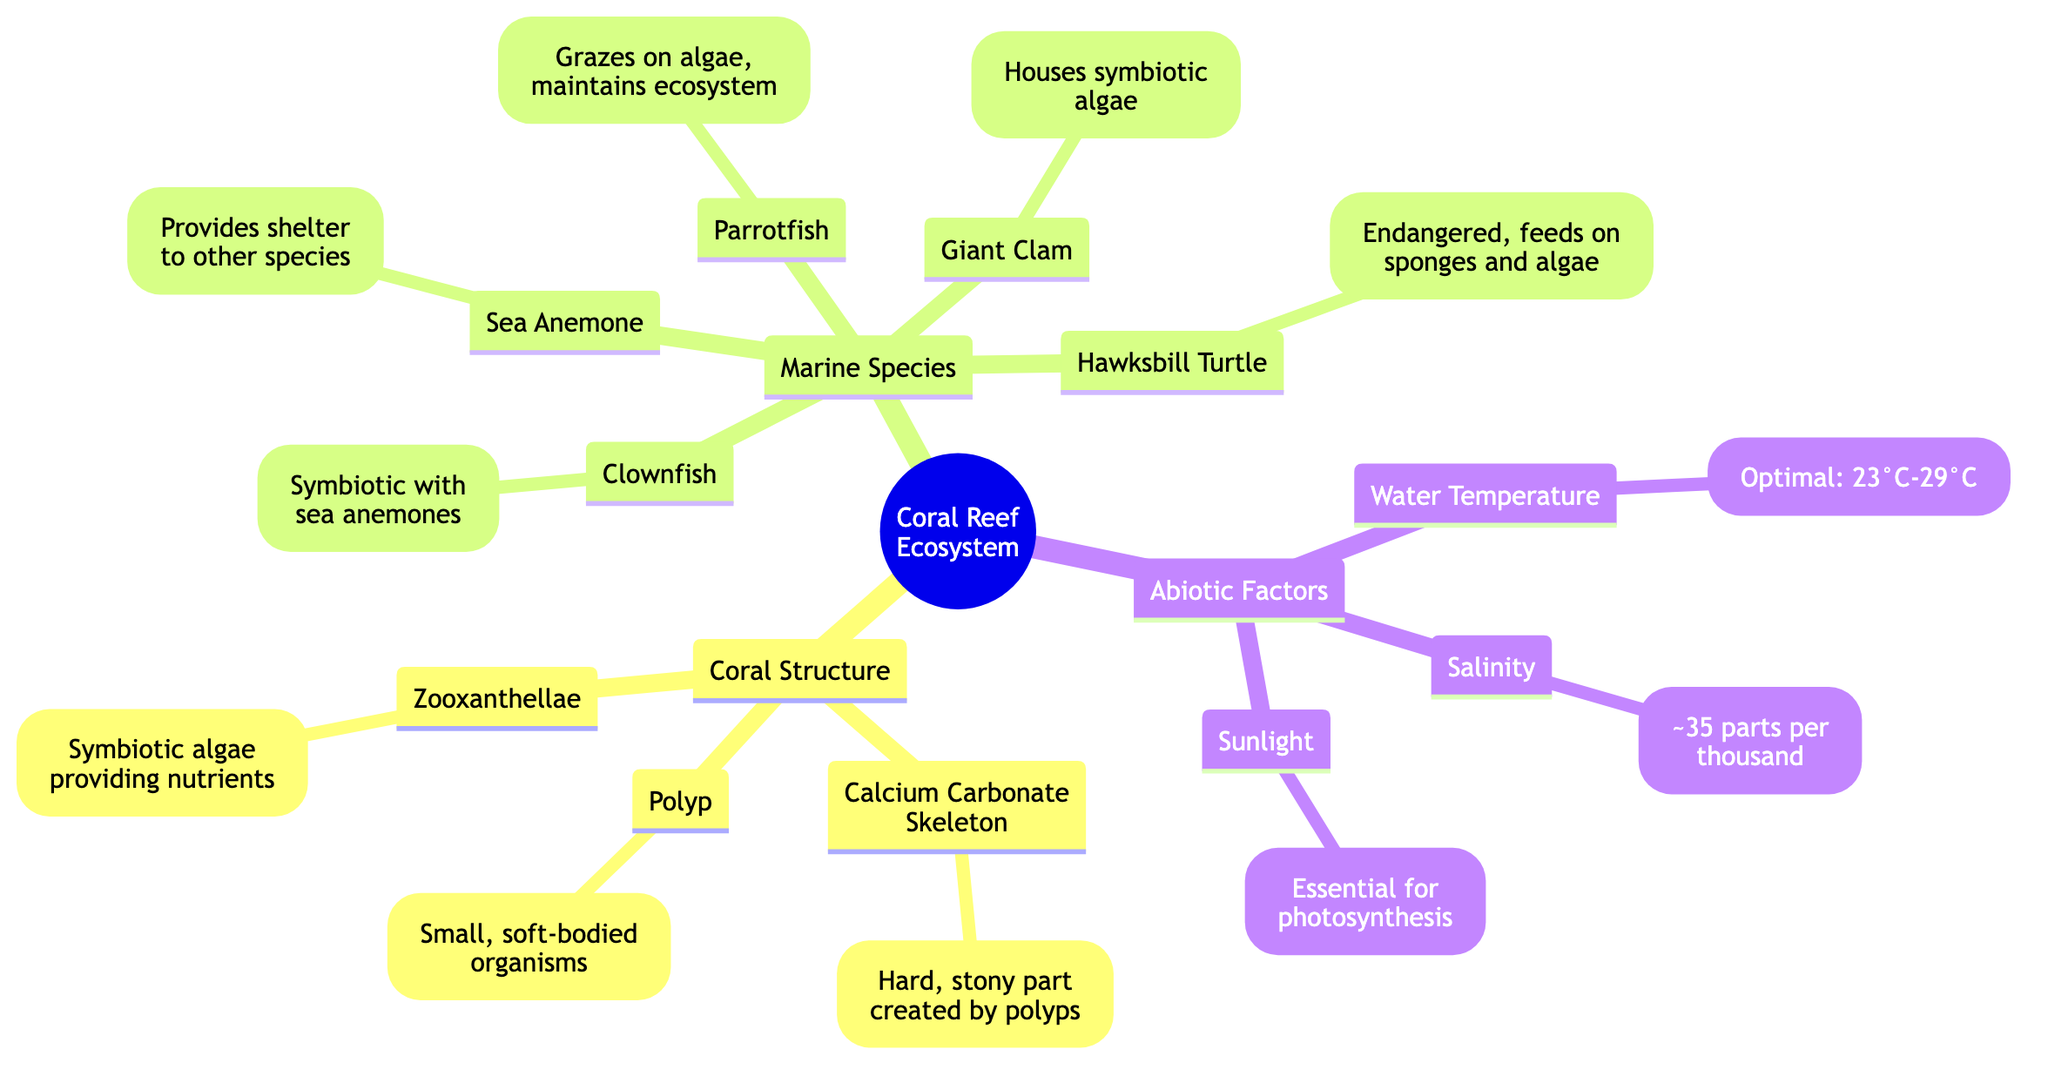What small, soft-bodied organisms are part of the coral structure? The diagram labels these organisms as "Polyp," indicating that they are small and soft-bodied. This information is directly stated under the "Polyp" section of the "Coral Structure."
Answer: Polyp Which marine species provides shelter to other species? The diagram indicates that "Sea Anemone" provides shelter to other species, as stated in the description under the "Marine Species" section.
Answer: Sea Anemone What is the optimal water temperature for a coral reef ecosystem? According to the diagram, the optimal water temperature is given as "23°C-29°C." This figure is clearly displayed under the "Abiotic Factors" section for "Water Temperature."
Answer: 23°C-29°C How many main components are there in the Coral Reef ecosystem identified in the diagram? The diagram shows three main components: "Coral Structure," "Marine Species," and "Abiotic Factors." Counting these components confirms the total number present.
Answer: 3 What role does the Parrotfish play in the coral reef ecosystem? The diagram states that "Parrotfish" grazes on algae and maintains the ecosystem, summarizing its role and importance in the coral reef.
Answer: Grazes on algae, maintains ecosystem What is the symbiotic relationship between Clownfish and another marine species? The diagram specifies that Clownfish are "Symbiotic with sea anemones," indicating an interdependent relationship between these two species.
Answer: Sea Anemones Which species is identified as endangered in the coral reef ecosystem? The diagram highlights "Hawksbill Turtle" as endangered and provides details regarding its feeding habits, identifying it specifically within the ecosystem.
Answer: Hawksbill Turtle What essential process is indicated to require sunlight in the coral reef ecosystem? The diagram specifies "photosynthesis" as the essential process that sunlight supports, indicating its critical role in the ecosystem's functioning.
Answer: Photosynthesis What type of algae is mentioned as providing nutrients to corals? The diagram labels "Zooxanthellae" as the symbiotic algae that provide nutrients, specifically indicating the relationship with corals.
Answer: Zooxanthellae 